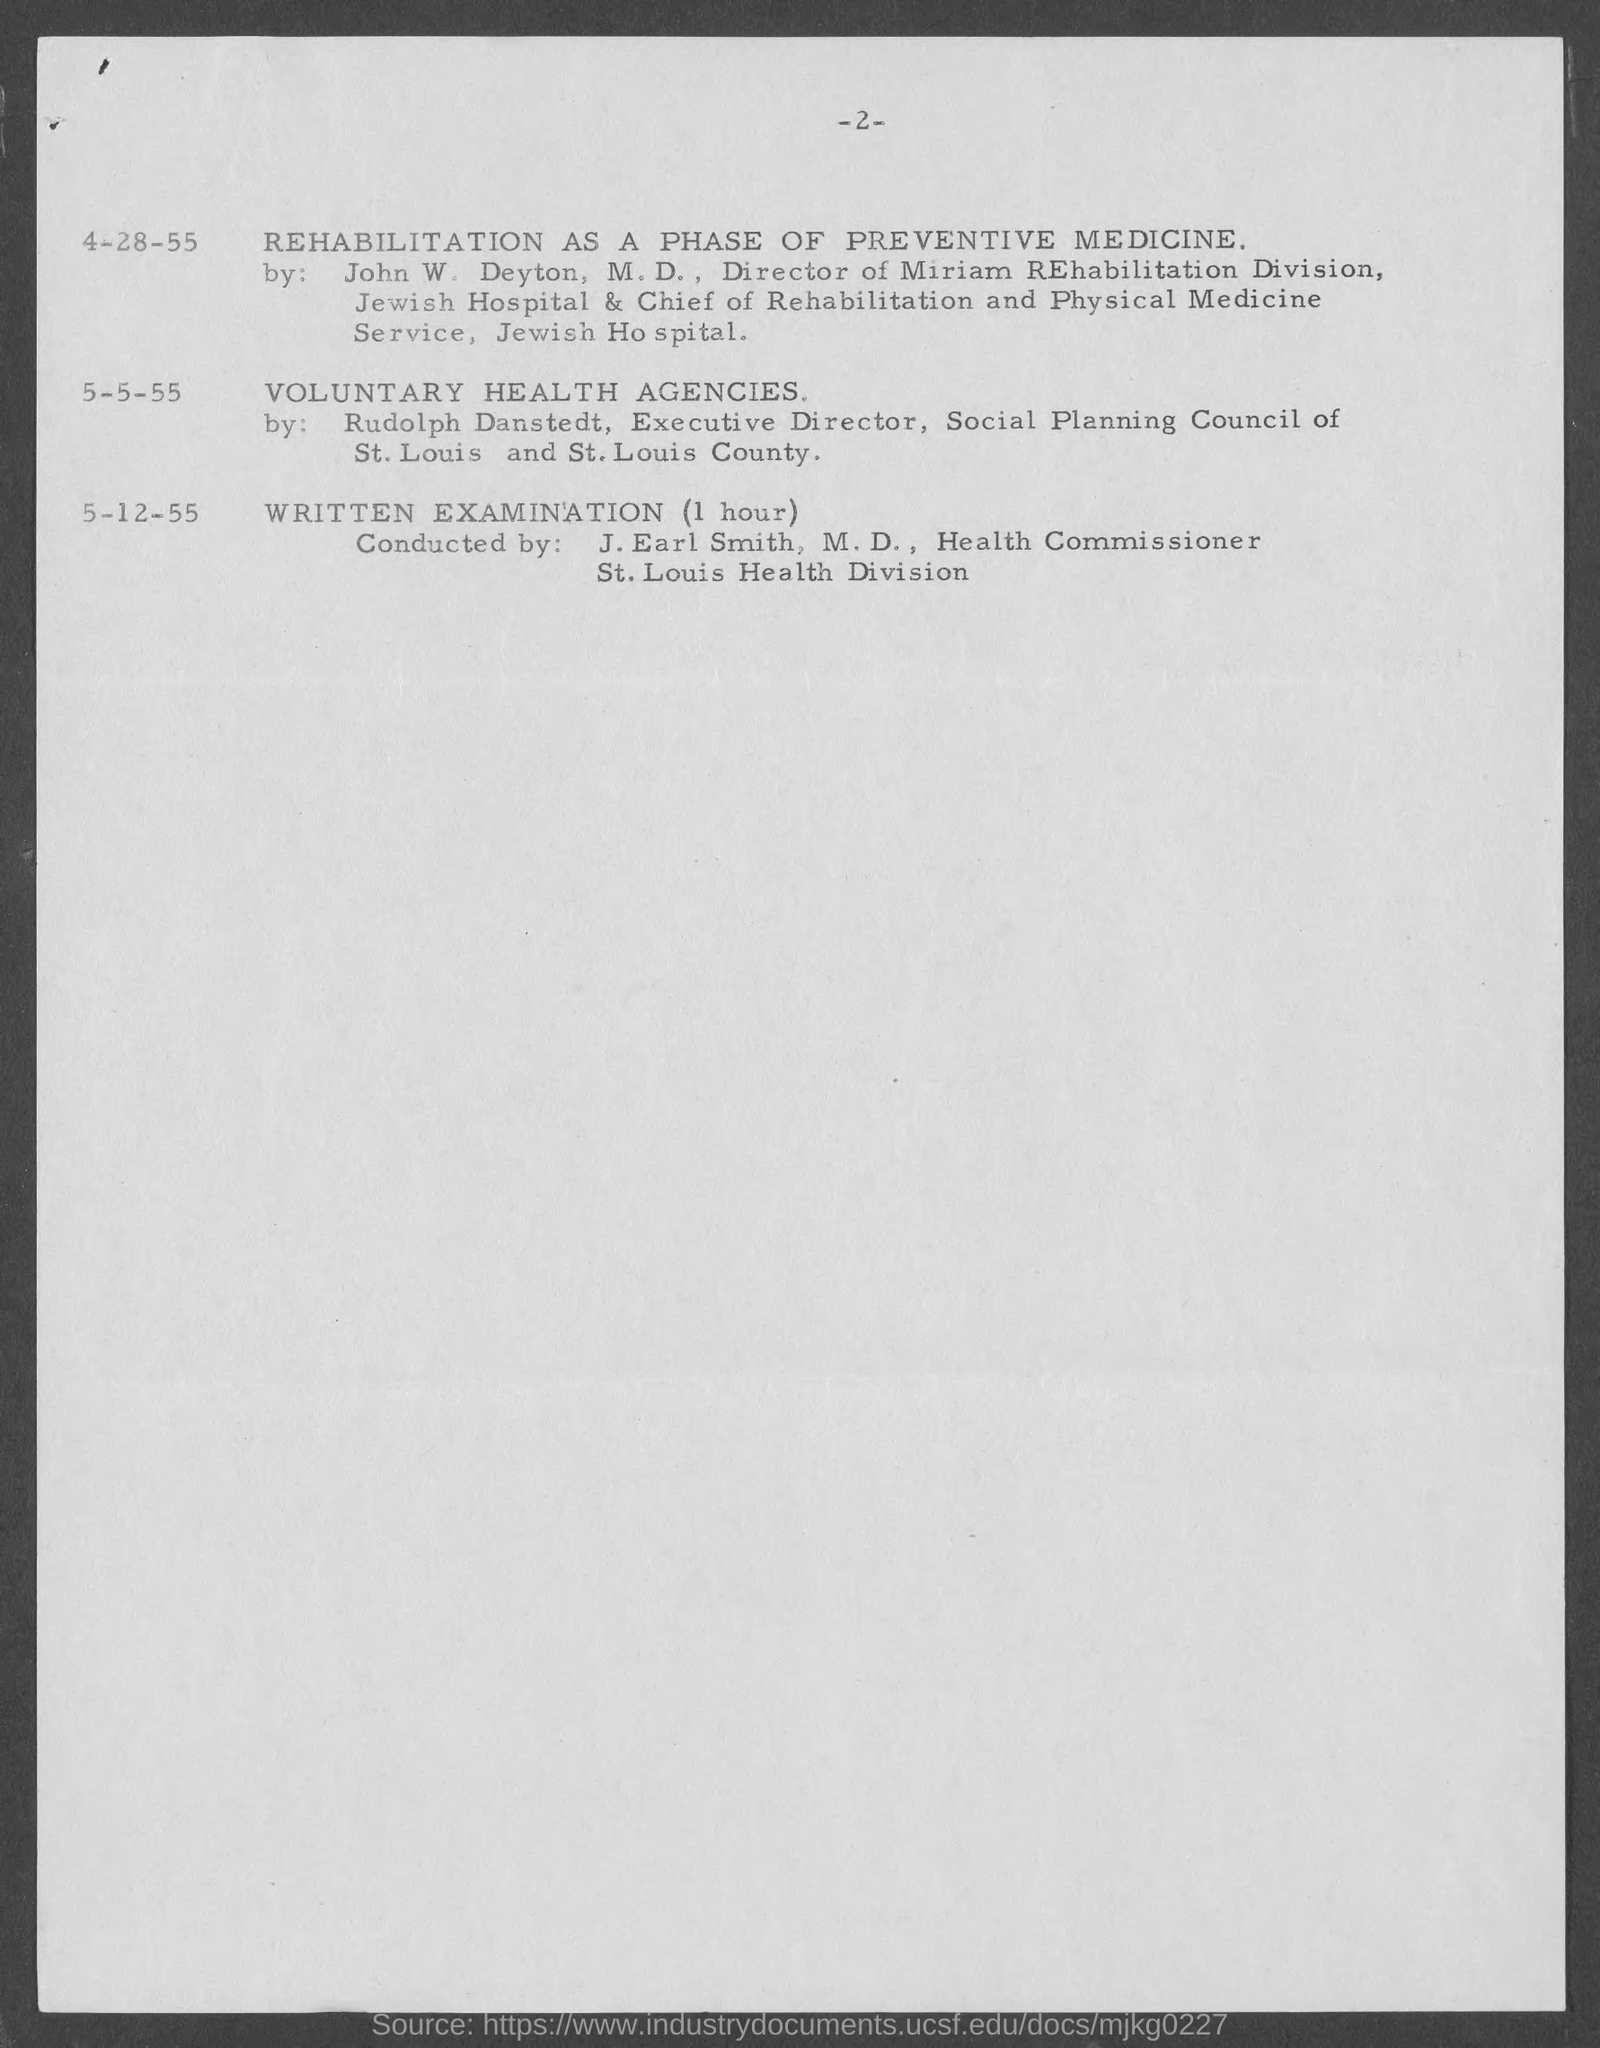What is the topic for 4-28-55?
Make the answer very short. Rehabilitation as a phase of preventive medicine. What is the duration for written examination?
Offer a terse response. 1 hour. When is the written examination?
Offer a terse response. 5-12-55. What is the designation of j. earl smith?
Your response must be concise. Health commissioner. 